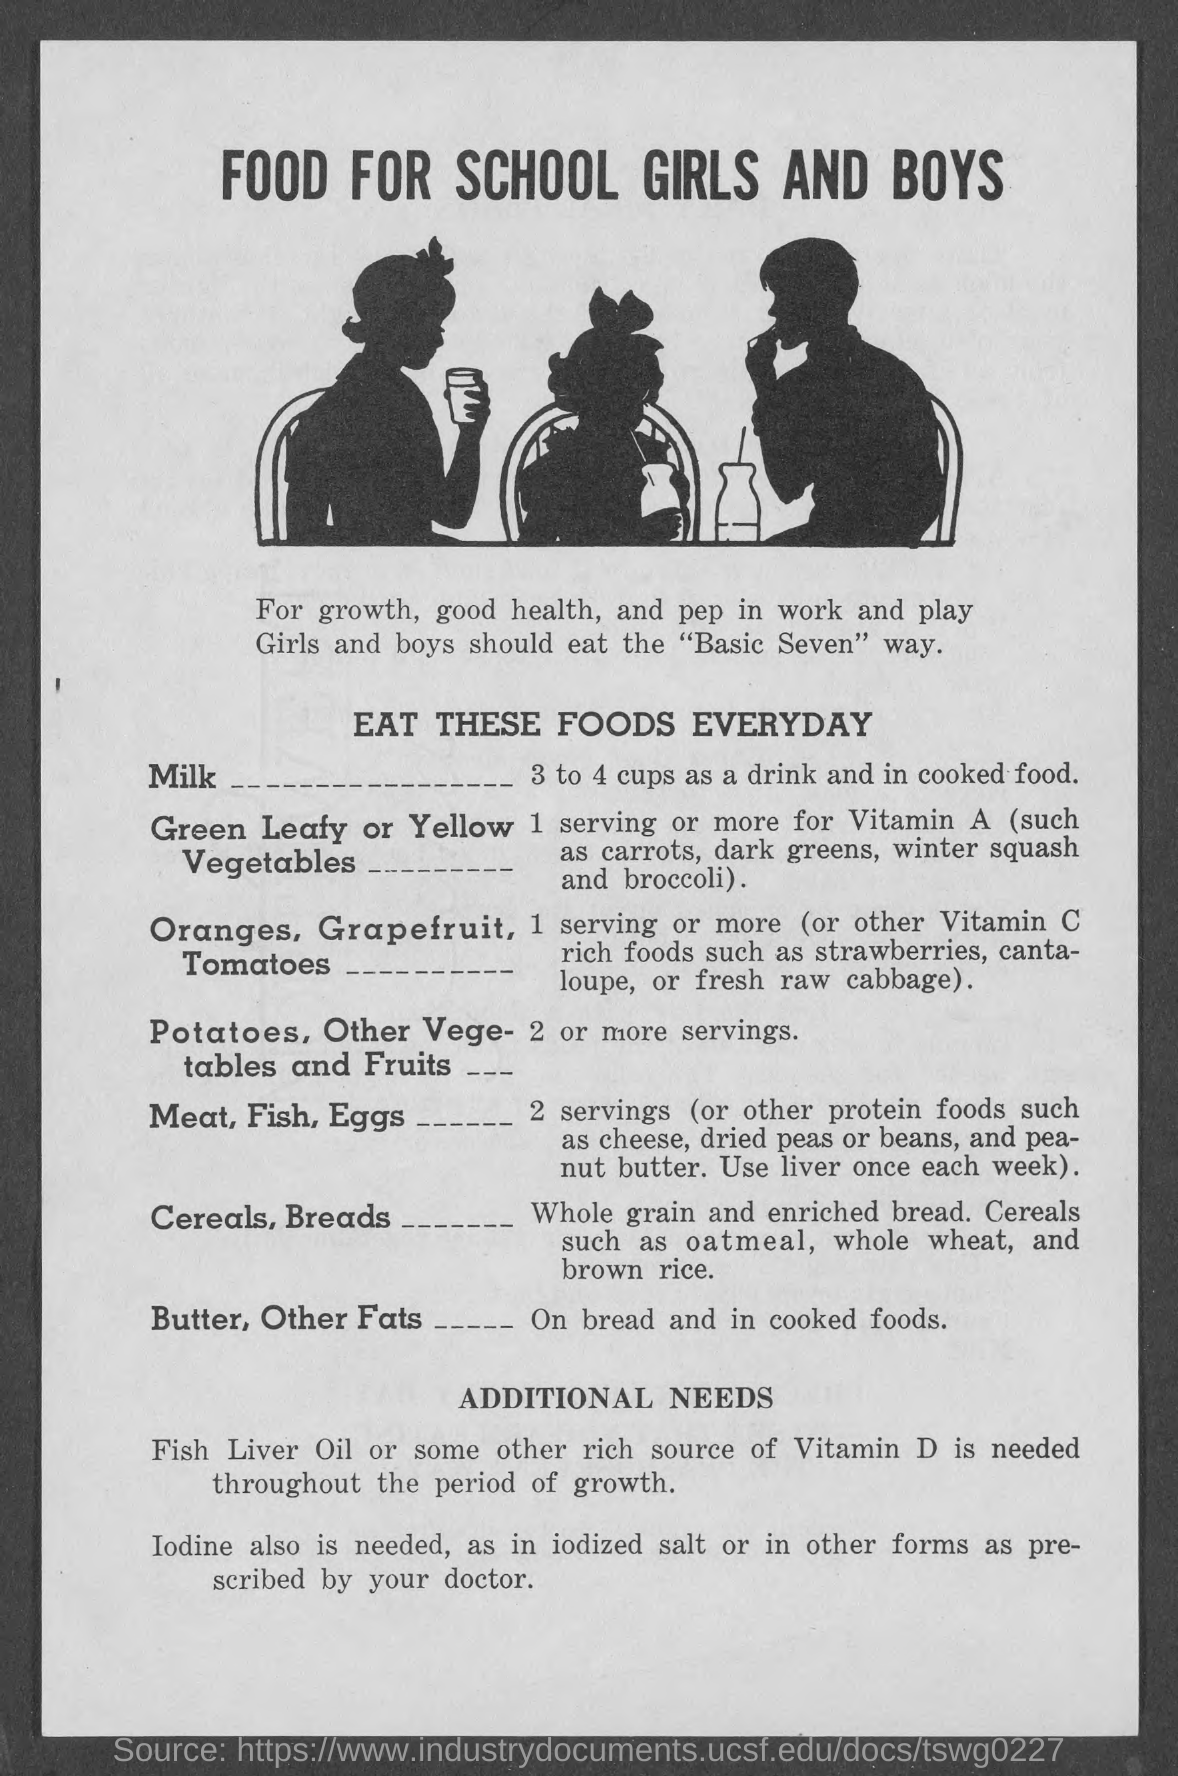How many cups of milk is needed every day?
Give a very brief answer. 3 to 4 cups. Which Vitamin is needed throughout life for growth?
Provide a short and direct response. Vitamin D. 